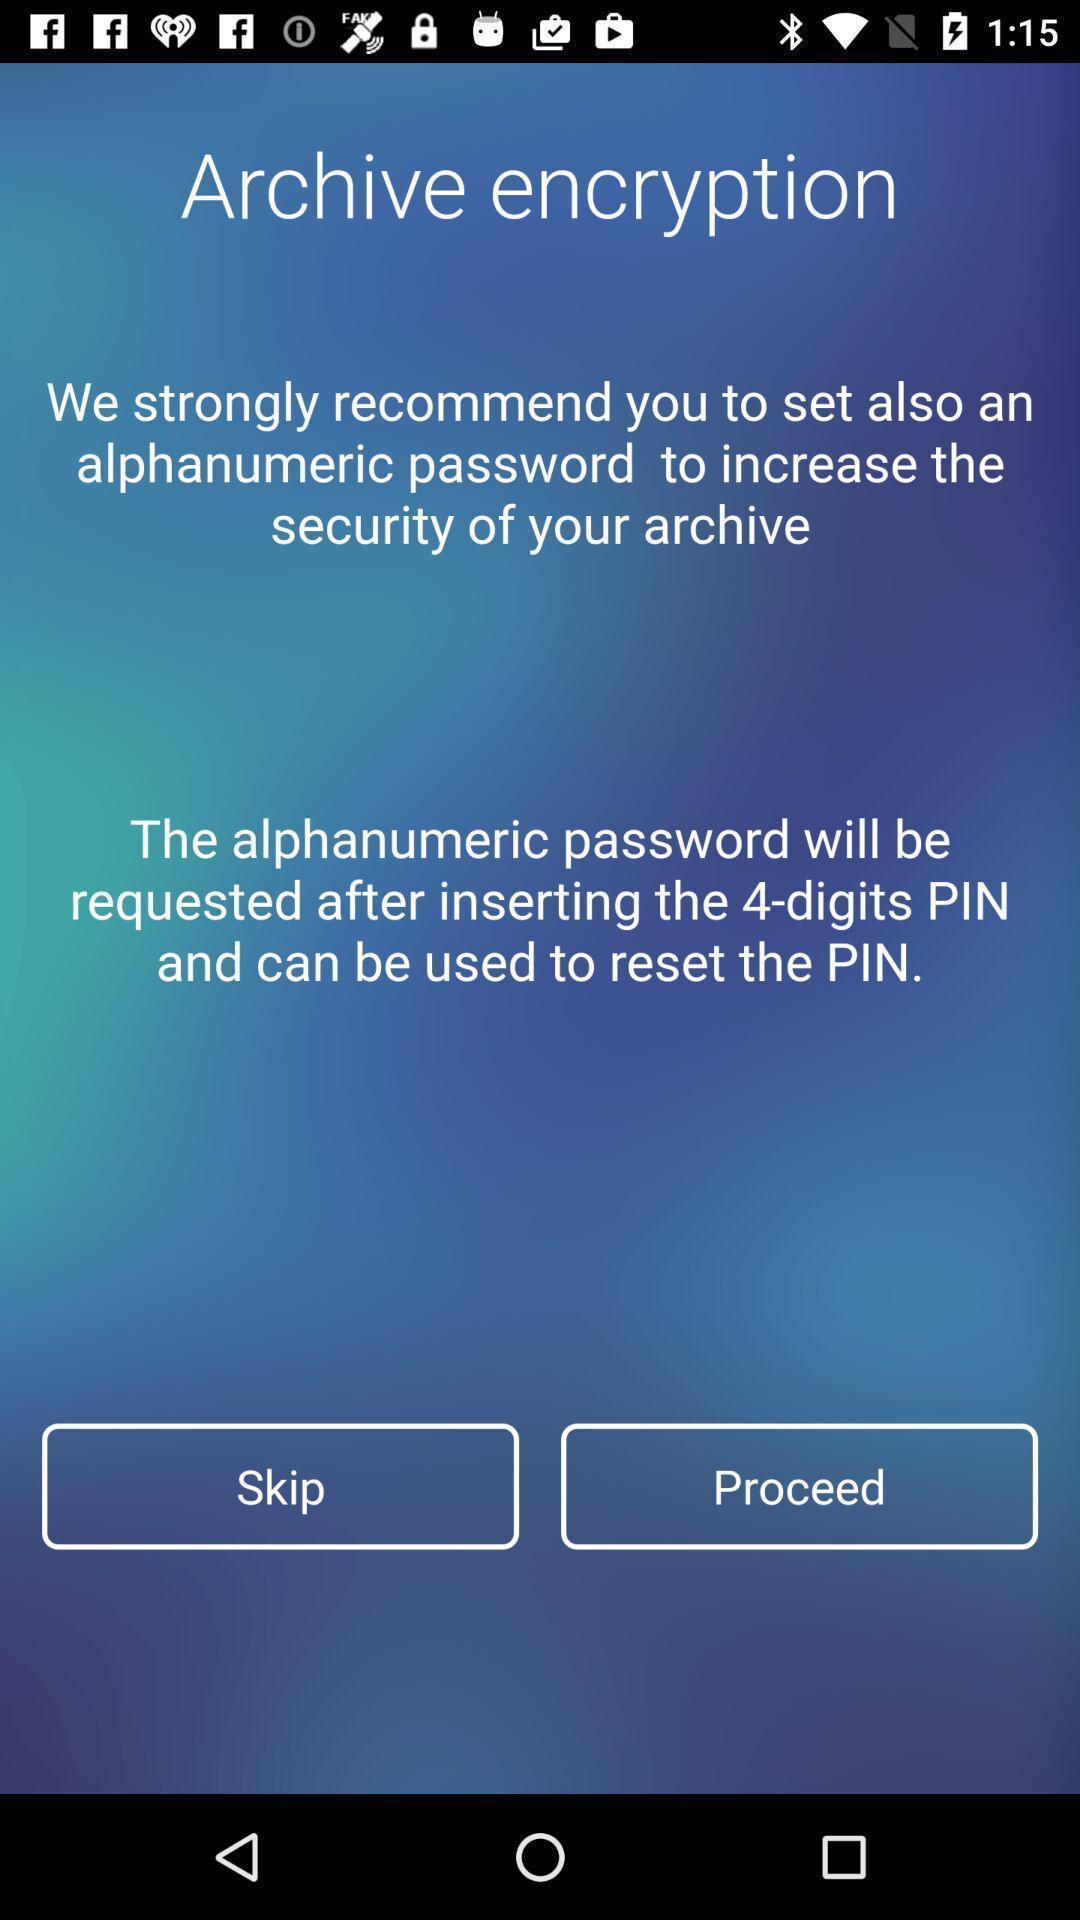Summarize the information in this screenshot. Welcome page of a business app. 